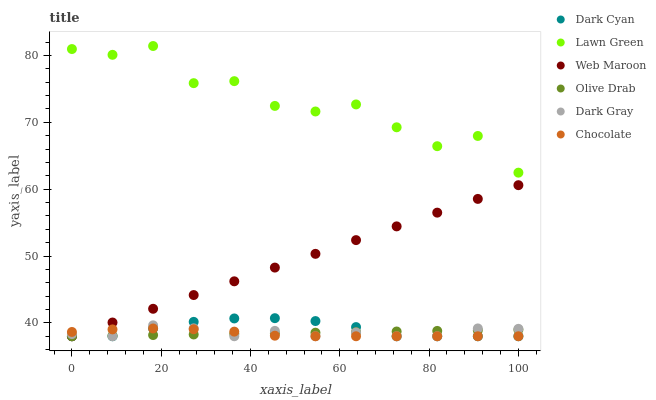Does Chocolate have the minimum area under the curve?
Answer yes or no. Yes. Does Lawn Green have the maximum area under the curve?
Answer yes or no. Yes. Does Web Maroon have the minimum area under the curve?
Answer yes or no. No. Does Web Maroon have the maximum area under the curve?
Answer yes or no. No. Is Olive Drab the smoothest?
Answer yes or no. Yes. Is Lawn Green the roughest?
Answer yes or no. Yes. Is Web Maroon the smoothest?
Answer yes or no. No. Is Web Maroon the roughest?
Answer yes or no. No. Does Web Maroon have the lowest value?
Answer yes or no. Yes. Does Lawn Green have the highest value?
Answer yes or no. Yes. Does Web Maroon have the highest value?
Answer yes or no. No. Is Web Maroon less than Lawn Green?
Answer yes or no. Yes. Is Lawn Green greater than Dark Cyan?
Answer yes or no. Yes. Does Web Maroon intersect Dark Cyan?
Answer yes or no. Yes. Is Web Maroon less than Dark Cyan?
Answer yes or no. No. Is Web Maroon greater than Dark Cyan?
Answer yes or no. No. Does Web Maroon intersect Lawn Green?
Answer yes or no. No. 